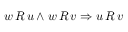Convert formula to latex. <formula><loc_0><loc_0><loc_500><loc_500>w \, R \, u \land w \, R \, v \Rightarrow u \, R \, v</formula> 